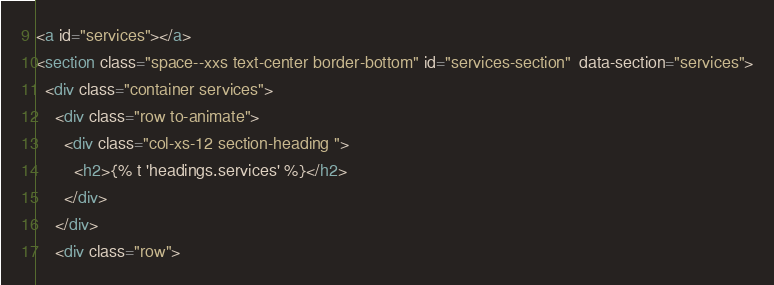Convert code to text. <code><loc_0><loc_0><loc_500><loc_500><_HTML_><a id="services"></a>
<section class="space--xxs text-center border-bottom" id="services-section"  data-section="services">
  <div class="container services">
    <div class="row to-animate">
      <div class="col-xs-12 section-heading ">
        <h2>{% t 'headings.services' %}</h2>
      </div>
    </div>
    <div class="row"></code> 